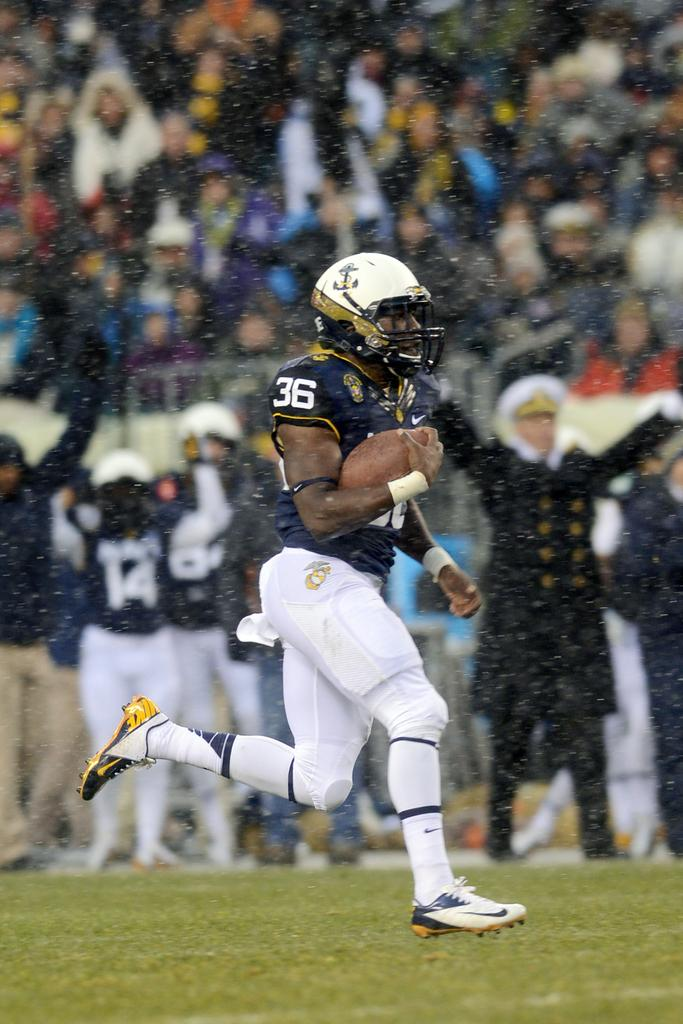Who is the main subject in the picture? There is a man in the center of the picture. What is the man holding in the picture? The man is holding a rugby ball. What is the man doing in the picture? The man is running. What type of surface is visible at the bottom of the picture? There is grass at the bottom of the picture. Can you describe the background of the picture? There are people in the background of the picture. What is the weather like in the picture? It is raining in the picture. What is the man's father doing in the picture? There is no mention of the man's father in the picture, so we cannot answer that question. What is the limit of the rugby ball in the picture? The facts provided do not mention any limits related to the rugby ball, so we cannot answer that question. 